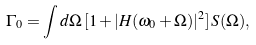<formula> <loc_0><loc_0><loc_500><loc_500>\Gamma _ { 0 } = \int d \Omega \, [ 1 + | H ( \omega _ { 0 } + \Omega ) | ^ { 2 } ] \, S ( \Omega ) ,</formula> 